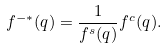<formula> <loc_0><loc_0><loc_500><loc_500>f ^ { - * } ( q ) = \frac { 1 } { f ^ { s } ( q ) } f ^ { c } ( q ) .</formula> 